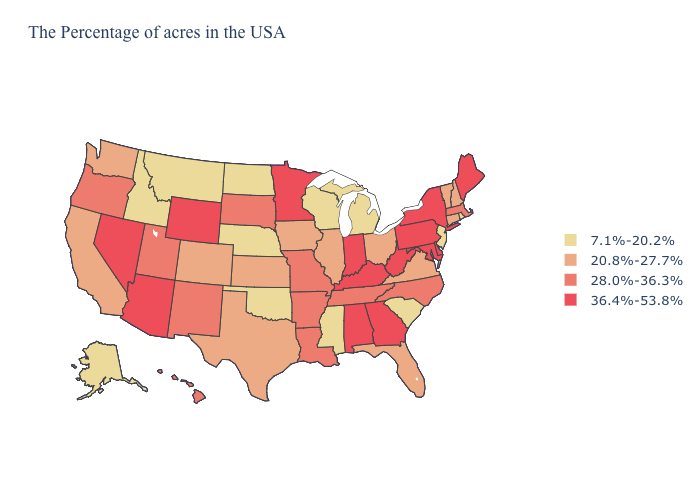Name the states that have a value in the range 20.8%-27.7%?
Keep it brief. New Hampshire, Vermont, Connecticut, Virginia, Ohio, Florida, Illinois, Iowa, Kansas, Texas, Colorado, California, Washington. What is the highest value in the USA?
Answer briefly. 36.4%-53.8%. Which states have the lowest value in the USA?
Write a very short answer. Rhode Island, New Jersey, South Carolina, Michigan, Wisconsin, Mississippi, Nebraska, Oklahoma, North Dakota, Montana, Idaho, Alaska. Name the states that have a value in the range 36.4%-53.8%?
Give a very brief answer. Maine, New York, Delaware, Maryland, Pennsylvania, West Virginia, Georgia, Kentucky, Indiana, Alabama, Minnesota, Wyoming, Arizona, Nevada. Which states have the lowest value in the Northeast?
Quick response, please. Rhode Island, New Jersey. What is the value of Rhode Island?
Short answer required. 7.1%-20.2%. Does Rhode Island have a higher value than South Dakota?
Give a very brief answer. No. Name the states that have a value in the range 36.4%-53.8%?
Quick response, please. Maine, New York, Delaware, Maryland, Pennsylvania, West Virginia, Georgia, Kentucky, Indiana, Alabama, Minnesota, Wyoming, Arizona, Nevada. Is the legend a continuous bar?
Write a very short answer. No. What is the highest value in states that border New Hampshire?
Be succinct. 36.4%-53.8%. What is the lowest value in the USA?
Concise answer only. 7.1%-20.2%. What is the value of Delaware?
Quick response, please. 36.4%-53.8%. Name the states that have a value in the range 7.1%-20.2%?
Concise answer only. Rhode Island, New Jersey, South Carolina, Michigan, Wisconsin, Mississippi, Nebraska, Oklahoma, North Dakota, Montana, Idaho, Alaska. Does the first symbol in the legend represent the smallest category?
Concise answer only. Yes. Name the states that have a value in the range 36.4%-53.8%?
Be succinct. Maine, New York, Delaware, Maryland, Pennsylvania, West Virginia, Georgia, Kentucky, Indiana, Alabama, Minnesota, Wyoming, Arizona, Nevada. 